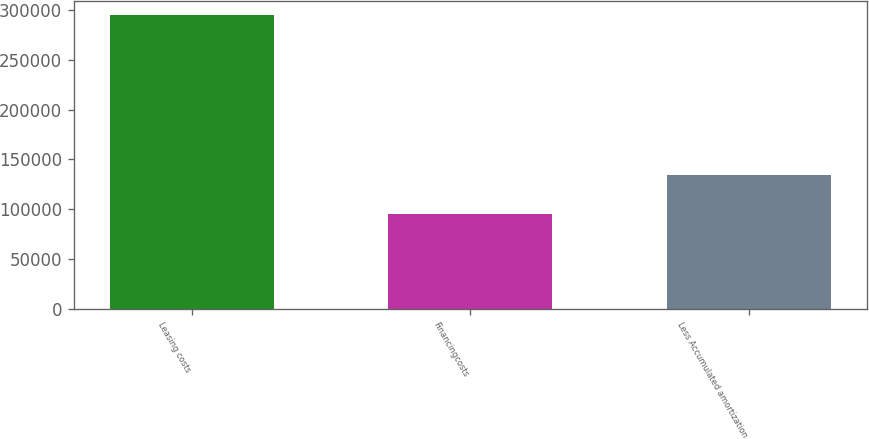<chart> <loc_0><loc_0><loc_500><loc_500><bar_chart><fcel>Leasing costs<fcel>Financingcosts<fcel>Less Accumulated amortization<nl><fcel>294405<fcel>95244<fcel>134699<nl></chart> 